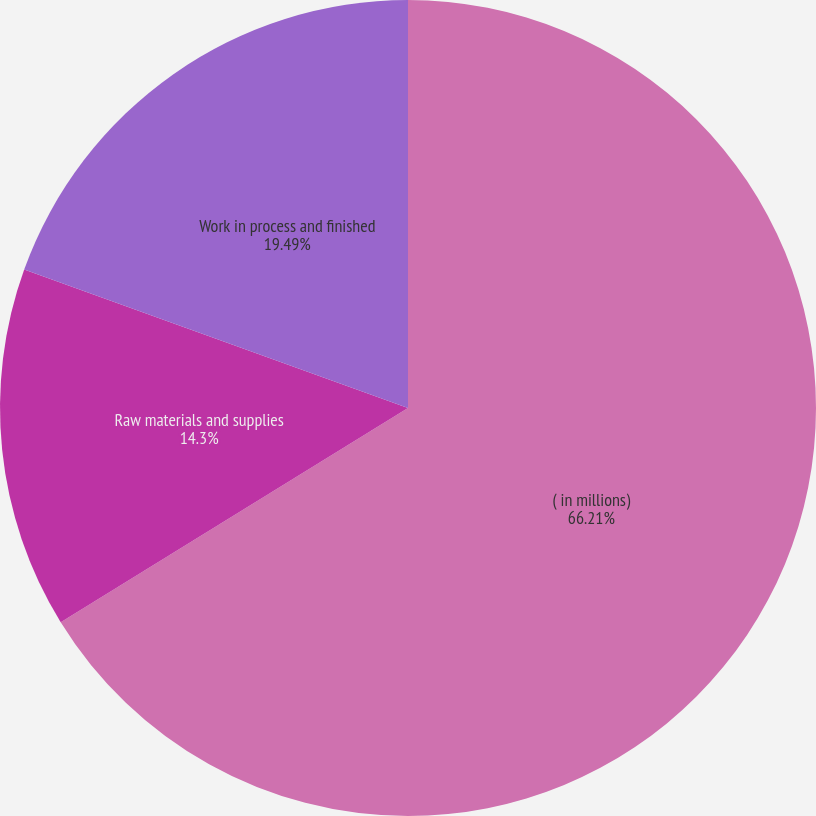Convert chart to OTSL. <chart><loc_0><loc_0><loc_500><loc_500><pie_chart><fcel>( in millions)<fcel>Raw materials and supplies<fcel>Work in process and finished<nl><fcel>66.2%<fcel>14.3%<fcel>19.49%<nl></chart> 